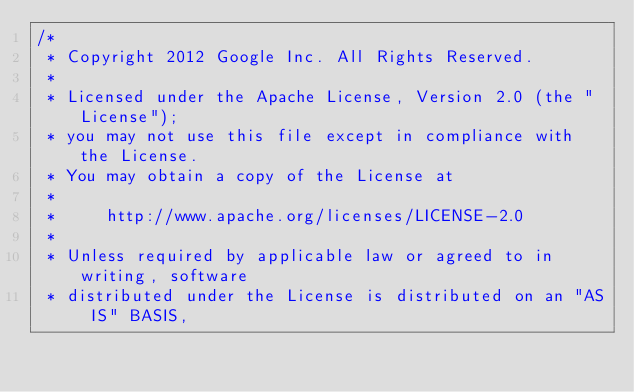Convert code to text. <code><loc_0><loc_0><loc_500><loc_500><_Java_>/*
 * Copyright 2012 Google Inc. All Rights Reserved.
 *
 * Licensed under the Apache License, Version 2.0 (the "License");
 * you may not use this file except in compliance with the License.
 * You may obtain a copy of the License at
 *
 *     http://www.apache.org/licenses/LICENSE-2.0
 *
 * Unless required by applicable law or agreed to in writing, software
 * distributed under the License is distributed on an "AS IS" BASIS,</code> 